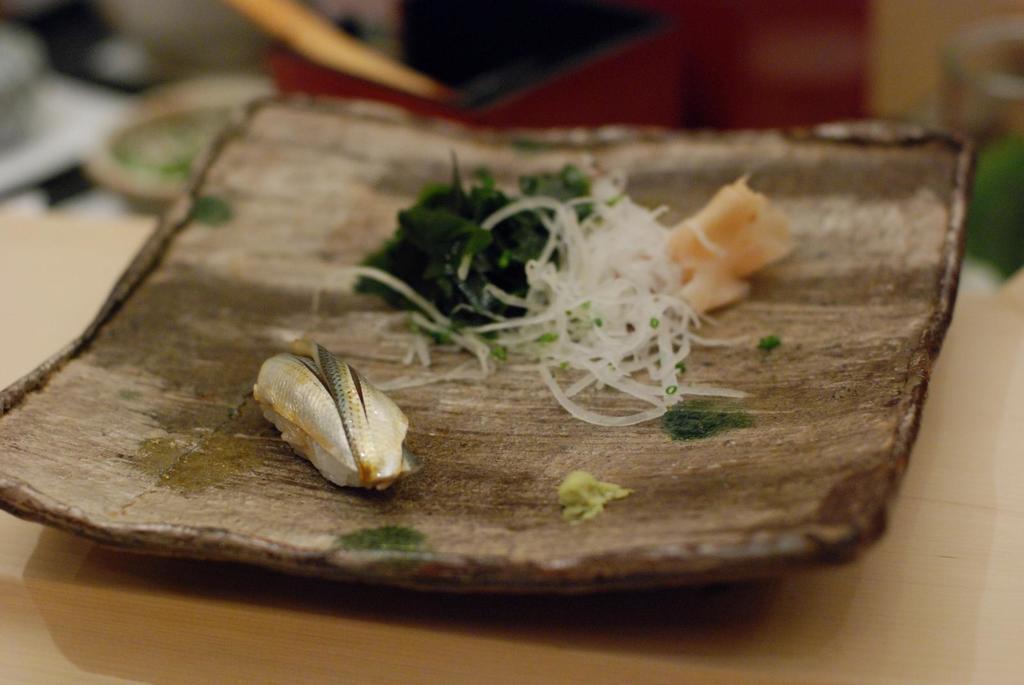Describe this image in one or two sentences. In this image I can see the brown colored surface and on it I can see a wooden plate which is brown in color. On the plate I can see a fish and few other food items which are green, white and cream in color. I can see the blurry background. 